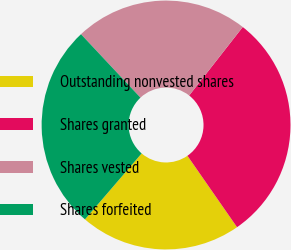Convert chart. <chart><loc_0><loc_0><loc_500><loc_500><pie_chart><fcel>Outstanding nonvested shares<fcel>Shares granted<fcel>Shares vested<fcel>Shares forfeited<nl><fcel>20.96%<fcel>29.77%<fcel>22.55%<fcel>26.72%<nl></chart> 